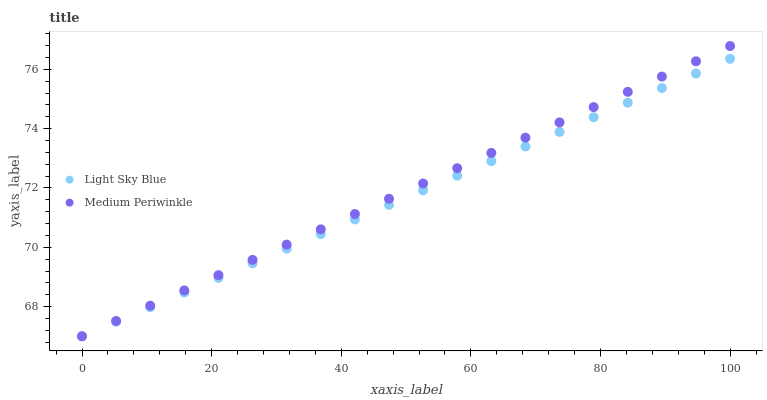Does Light Sky Blue have the minimum area under the curve?
Answer yes or no. Yes. Does Medium Periwinkle have the maximum area under the curve?
Answer yes or no. Yes. Does Medium Periwinkle have the minimum area under the curve?
Answer yes or no. No. Is Medium Periwinkle the smoothest?
Answer yes or no. Yes. Is Light Sky Blue the roughest?
Answer yes or no. Yes. Is Medium Periwinkle the roughest?
Answer yes or no. No. Does Light Sky Blue have the lowest value?
Answer yes or no. Yes. Does Medium Periwinkle have the highest value?
Answer yes or no. Yes. Does Light Sky Blue intersect Medium Periwinkle?
Answer yes or no. Yes. Is Light Sky Blue less than Medium Periwinkle?
Answer yes or no. No. Is Light Sky Blue greater than Medium Periwinkle?
Answer yes or no. No. 